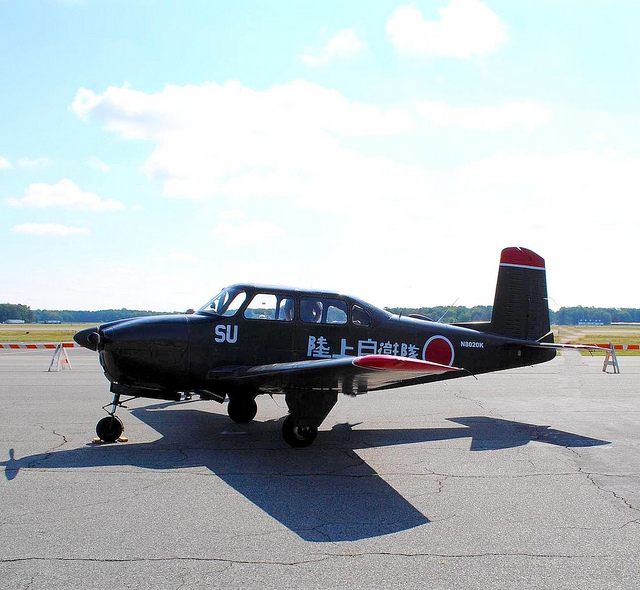Please transcribe the text information in this image. SU 